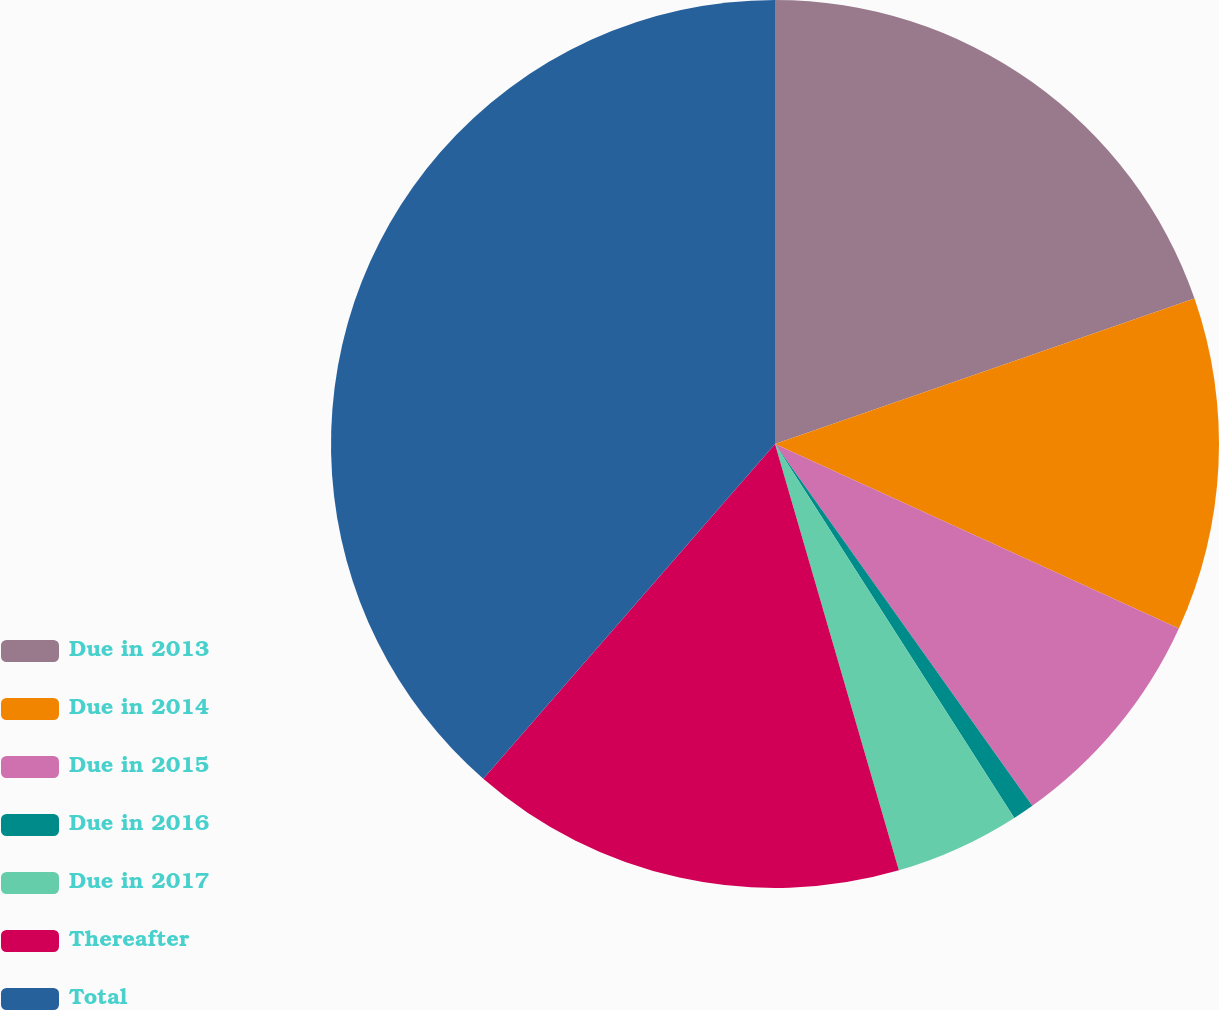Convert chart to OTSL. <chart><loc_0><loc_0><loc_500><loc_500><pie_chart><fcel>Due in 2013<fcel>Due in 2014<fcel>Due in 2015<fcel>Due in 2016<fcel>Due in 2017<fcel>Thereafter<fcel>Total<nl><fcel>19.69%<fcel>12.13%<fcel>8.34%<fcel>0.78%<fcel>4.56%<fcel>15.91%<fcel>38.59%<nl></chart> 